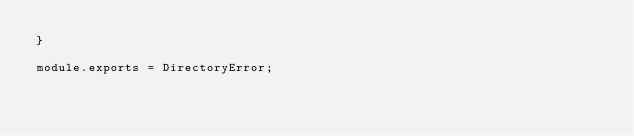<code> <loc_0><loc_0><loc_500><loc_500><_JavaScript_>}

module.exports = DirectoryError;
</code> 